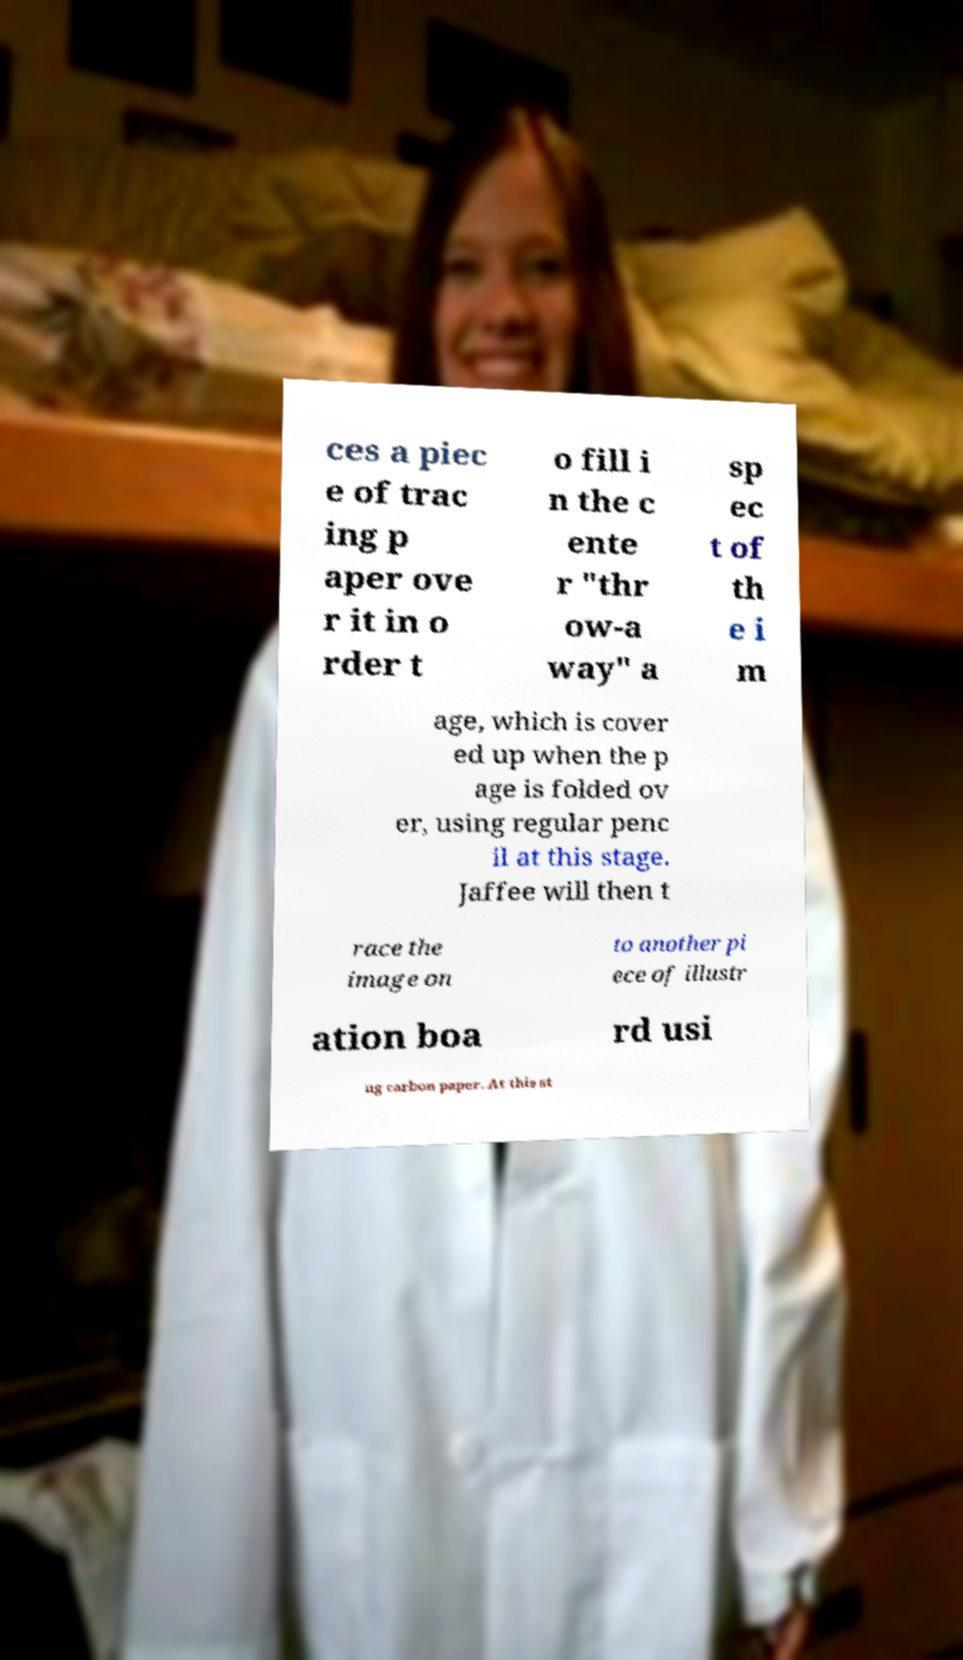Can you accurately transcribe the text from the provided image for me? ces a piec e of trac ing p aper ove r it in o rder t o fill i n the c ente r "thr ow-a way" a sp ec t of th e i m age, which is cover ed up when the p age is folded ov er, using regular penc il at this stage. Jaffee will then t race the image on to another pi ece of illustr ation boa rd usi ng carbon paper. At this st 